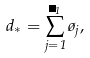<formula> <loc_0><loc_0><loc_500><loc_500>d _ { * } = \sum _ { j = 1 } ^ { \Lambda _ { 1 } } \tau _ { j } ,</formula> 